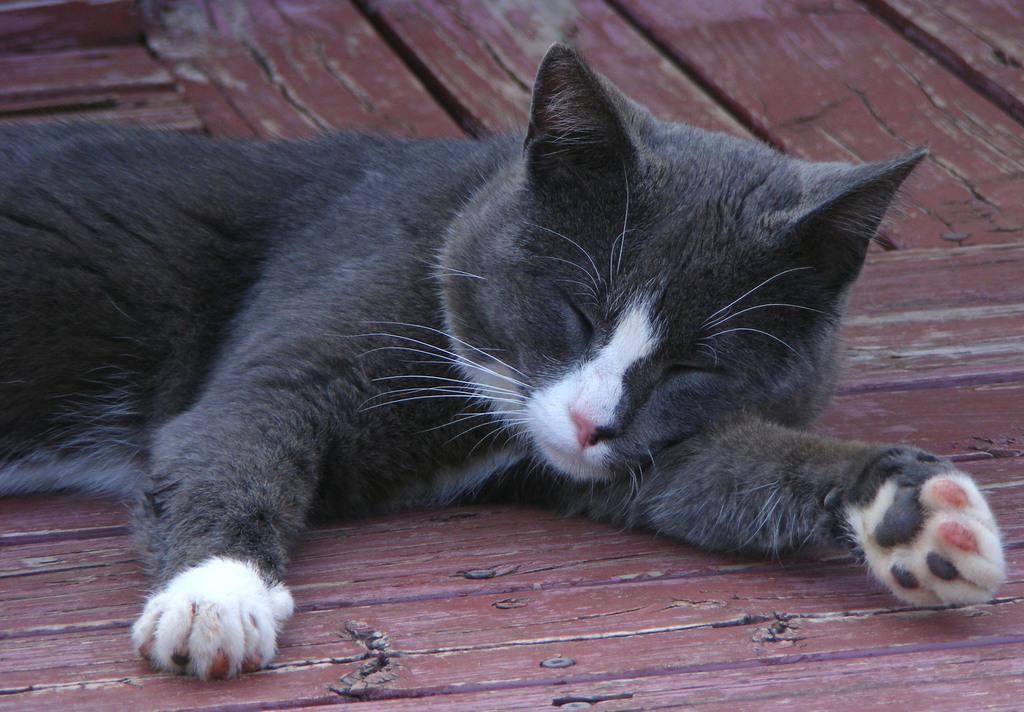Please provide a concise description of this image. In this image we can see a cat on the wooden platform. 